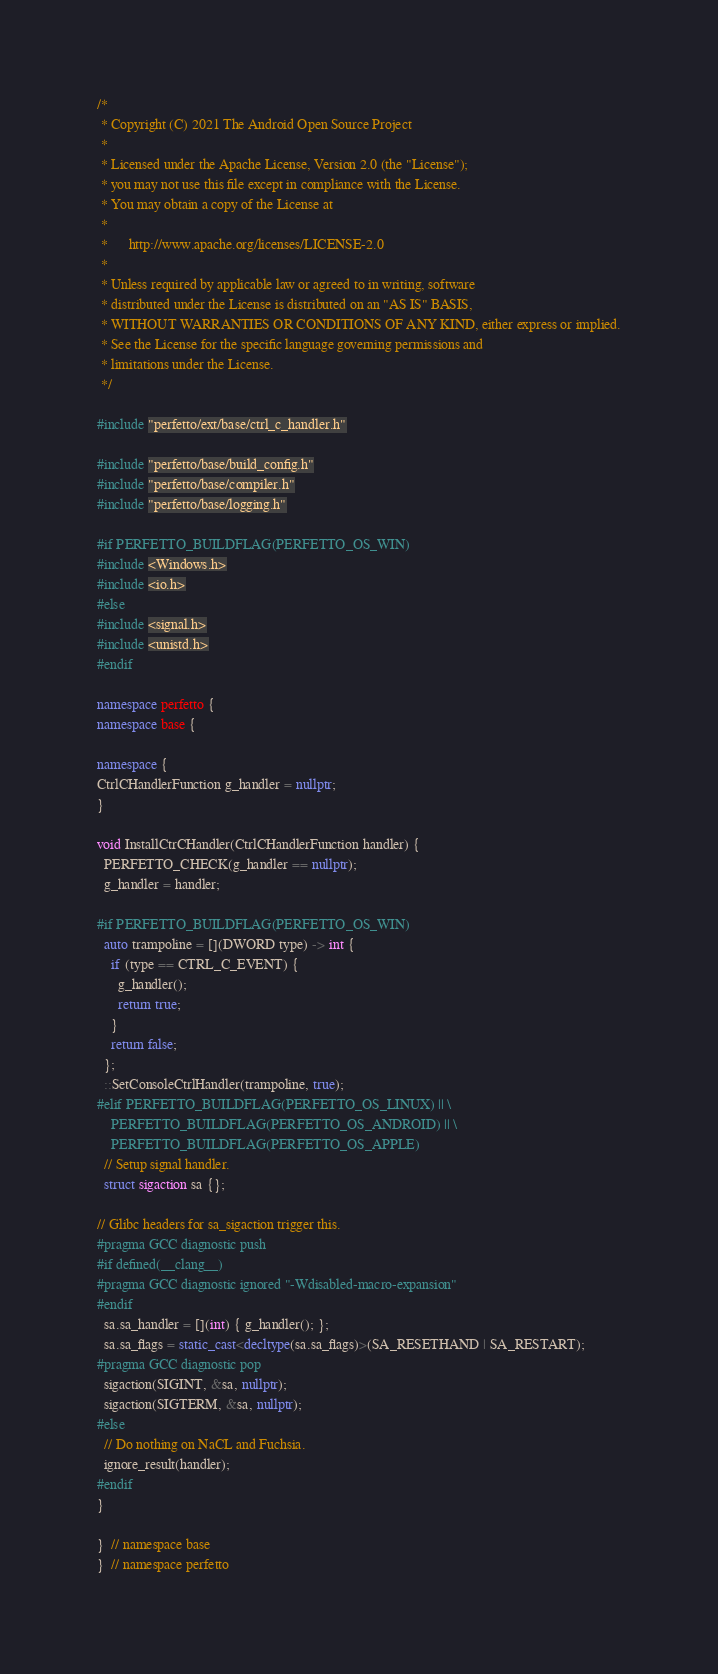<code> <loc_0><loc_0><loc_500><loc_500><_C++_>/*
 * Copyright (C) 2021 The Android Open Source Project
 *
 * Licensed under the Apache License, Version 2.0 (the "License");
 * you may not use this file except in compliance with the License.
 * You may obtain a copy of the License at
 *
 *      http://www.apache.org/licenses/LICENSE-2.0
 *
 * Unless required by applicable law or agreed to in writing, software
 * distributed under the License is distributed on an "AS IS" BASIS,
 * WITHOUT WARRANTIES OR CONDITIONS OF ANY KIND, either express or implied.
 * See the License for the specific language governing permissions and
 * limitations under the License.
 */

#include "perfetto/ext/base/ctrl_c_handler.h"

#include "perfetto/base/build_config.h"
#include "perfetto/base/compiler.h"
#include "perfetto/base/logging.h"

#if PERFETTO_BUILDFLAG(PERFETTO_OS_WIN)
#include <Windows.h>
#include <io.h>
#else
#include <signal.h>
#include <unistd.h>
#endif

namespace perfetto {
namespace base {

namespace {
CtrlCHandlerFunction g_handler = nullptr;
}

void InstallCtrCHandler(CtrlCHandlerFunction handler) {
  PERFETTO_CHECK(g_handler == nullptr);
  g_handler = handler;

#if PERFETTO_BUILDFLAG(PERFETTO_OS_WIN)
  auto trampoline = [](DWORD type) -> int {
    if (type == CTRL_C_EVENT) {
      g_handler();
      return true;
    }
    return false;
  };
  ::SetConsoleCtrlHandler(trampoline, true);
#elif PERFETTO_BUILDFLAG(PERFETTO_OS_LINUX) || \
    PERFETTO_BUILDFLAG(PERFETTO_OS_ANDROID) || \
    PERFETTO_BUILDFLAG(PERFETTO_OS_APPLE)
  // Setup signal handler.
  struct sigaction sa {};

// Glibc headers for sa_sigaction trigger this.
#pragma GCC diagnostic push
#if defined(__clang__)
#pragma GCC diagnostic ignored "-Wdisabled-macro-expansion"
#endif
  sa.sa_handler = [](int) { g_handler(); };
  sa.sa_flags = static_cast<decltype(sa.sa_flags)>(SA_RESETHAND | SA_RESTART);
#pragma GCC diagnostic pop
  sigaction(SIGINT, &sa, nullptr);
  sigaction(SIGTERM, &sa, nullptr);
#else
  // Do nothing on NaCL and Fuchsia.
  ignore_result(handler);
#endif
}

}  // namespace base
}  // namespace perfetto
</code> 